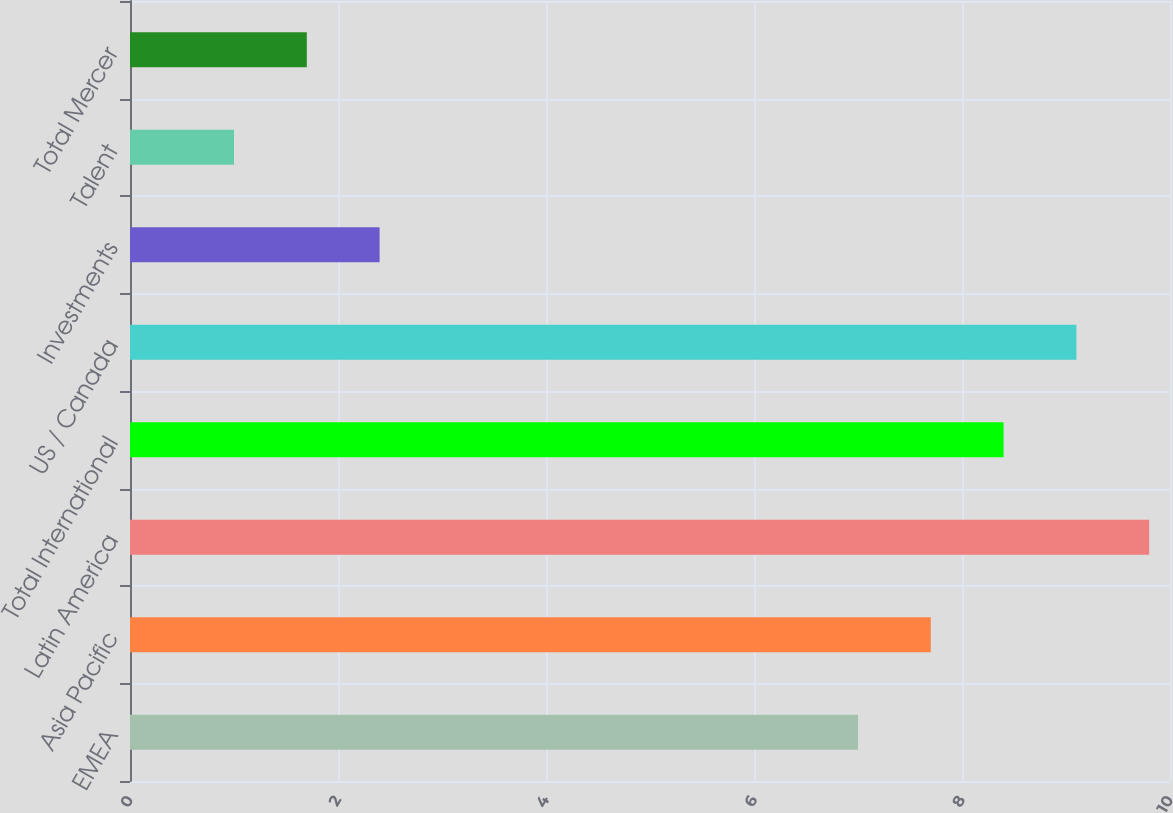Convert chart. <chart><loc_0><loc_0><loc_500><loc_500><bar_chart><fcel>EMEA<fcel>Asia Pacific<fcel>Latin America<fcel>Total International<fcel>US / Canada<fcel>Investments<fcel>Talent<fcel>Total Mercer<nl><fcel>7<fcel>7.7<fcel>9.8<fcel>8.4<fcel>9.1<fcel>2.4<fcel>1<fcel>1.7<nl></chart> 